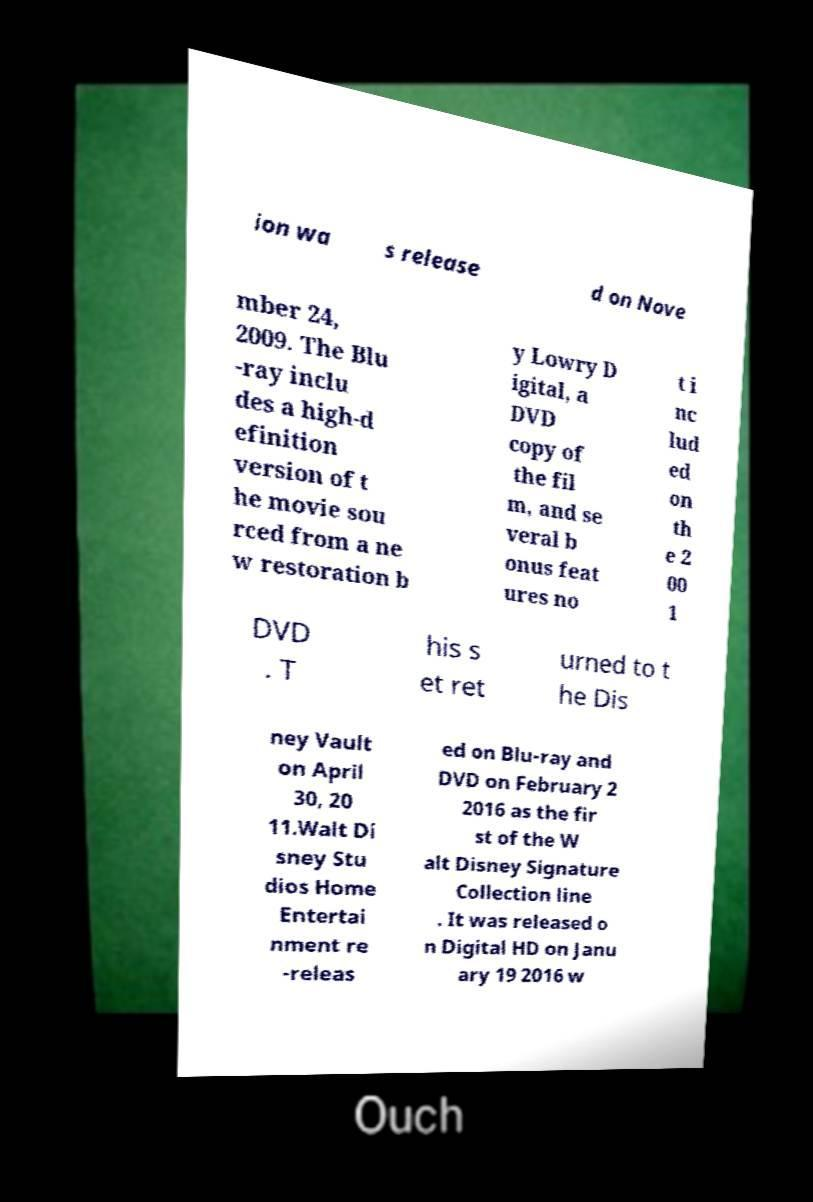I need the written content from this picture converted into text. Can you do that? ion wa s release d on Nove mber 24, 2009. The Blu -ray inclu des a high-d efinition version of t he movie sou rced from a ne w restoration b y Lowry D igital, a DVD copy of the fil m, and se veral b onus feat ures no t i nc lud ed on th e 2 00 1 DVD . T his s et ret urned to t he Dis ney Vault on April 30, 20 11.Walt Di sney Stu dios Home Entertai nment re -releas ed on Blu-ray and DVD on February 2 2016 as the fir st of the W alt Disney Signature Collection line . It was released o n Digital HD on Janu ary 19 2016 w 